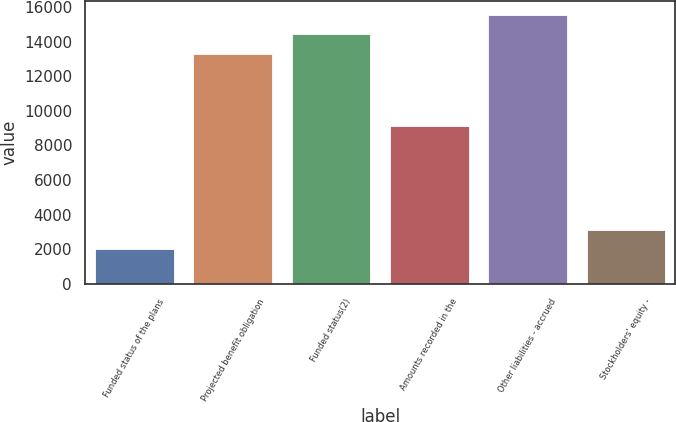Convert chart to OTSL. <chart><loc_0><loc_0><loc_500><loc_500><bar_chart><fcel>Funded status of the plans<fcel>Projected benefit obligation<fcel>Funded status(2)<fcel>Amounts recorded in the<fcel>Other liabilities - accrued<fcel>Stockholders' equity -<nl><fcel>2008<fcel>13286<fcel>14413.8<fcel>9141<fcel>15541.6<fcel>3135.8<nl></chart> 